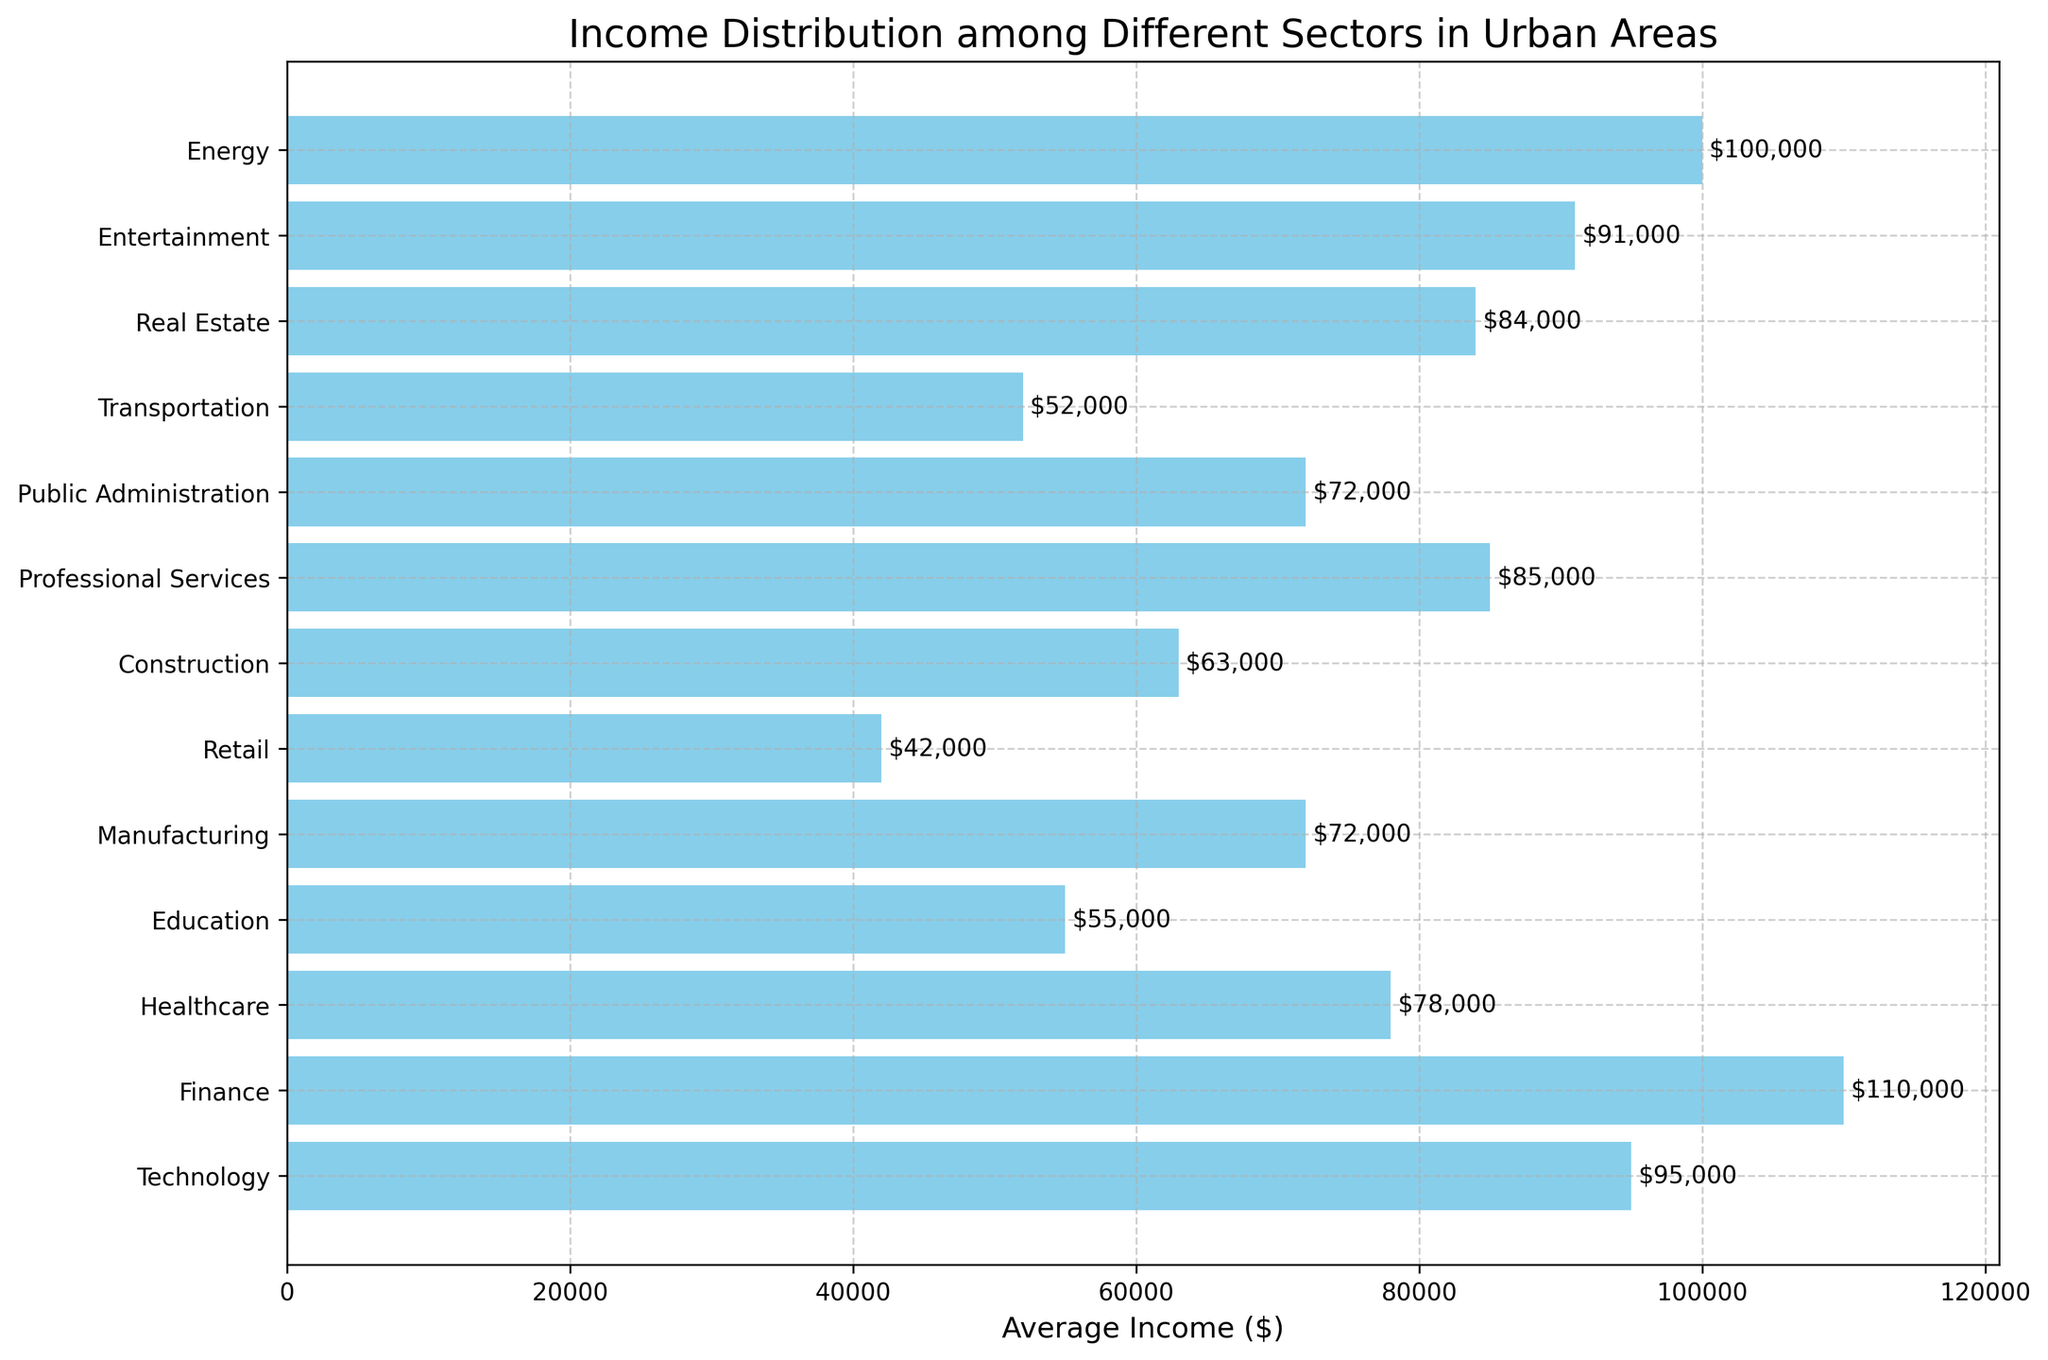Which sector has the highest average income? To determine this, scan the bar chart for the longest bar, which represents the highest average income value.
Answer: Finance Which sector has the lowest average income? Look for the shortest bar on the bar chart, indicating the lowest average income.
Answer: Retail What is the difference between the average income in the Technology sector and the Retail sector? Find the lengths of the bars representing Technology and Retail sectors, then subtract the Retail sector's average income from the Technology sector's average income: 95000 - 42000 = 53000.
Answer: 53000 What is the total average income for the Healthcare, Education, and Manufacturing sectors? Sum the average incomes of the Healthcare, Education, and Manufacturing sectors: 78000 + 55000 + 72000 = 205000.
Answer: 205000 Which sector has a higher average income, Professional Services or Real Estate? Compare the lengths of the bars for Professional Services and Real Estate sectors to see which is longer.
Answer: Professional Services By how much does the average income of the Energy sector exceed that of the Public Administration sector? Subtract the average income of the Public Administration sector from the Energy sector's average income: 100000 - 72000 = 28000.
Answer: 28000 What is the median average income among all sectors? Order the average incomes and find the middle value: 42000, 52000, 55000, 63000, 72000, 72000, 78000, 84000, 85000, 91000, 95000, 100000, 110000. The median is the 7th value: 78000.
Answer: 78000 Which sector's average income closely matches the median average income of all sectors? Refer to the ordered list of average incomes and find the sector corresponding to the median value 78000.
Answer: Healthcare Are there more sectors with average incomes above or below 80,000? Count the number of bars above and below the $80,000 mark. 6 sectors have incomes above $80,000 and 7 sectors have incomes below $80,000.
Answer: Below 